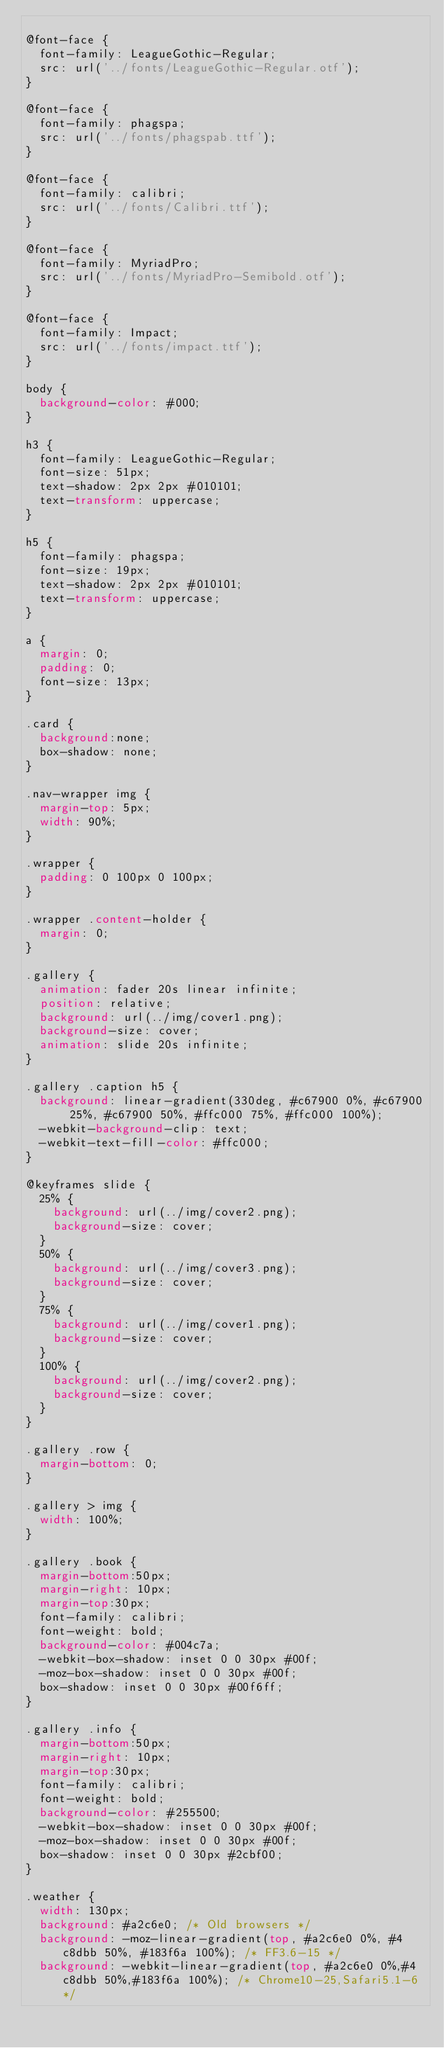<code> <loc_0><loc_0><loc_500><loc_500><_CSS_>
@font-face {
  font-family: LeagueGothic-Regular;
  src: url('../fonts/LeagueGothic-Regular.otf');
}

@font-face {
  font-family: phagspa;
  src: url('../fonts/phagspab.ttf');
}

@font-face {
  font-family: calibri;
  src: url('../fonts/Calibri.ttf');
}

@font-face {
  font-family: MyriadPro;
  src: url('../fonts/MyriadPro-Semibold.otf');
}

@font-face {
  font-family: Impact;
  src: url('../fonts/impact.ttf');
}

body {
  background-color: #000;
}

h3 {
  font-family: LeagueGothic-Regular;
  font-size: 51px;
  text-shadow: 2px 2px #010101;
  text-transform: uppercase;
}

h5 {
  font-family: phagspa;
  font-size: 19px;
  text-shadow: 2px 2px #010101;
  text-transform: uppercase;
}

a {
  margin: 0;
  padding: 0;
  font-size: 13px;
}

.card {
  background:none;
  box-shadow: none;
}

.nav-wrapper img {
  margin-top: 5px;
  width: 90%;
}

.wrapper {
  padding: 0 100px 0 100px;
}

.wrapper .content-holder {
  margin: 0;
}

.gallery {
  animation: fader 20s linear infinite;
  position: relative;
  background: url(../img/cover1.png);
  background-size: cover;
  animation: slide 20s infinite;
}

.gallery .caption h5 {
  background: linear-gradient(330deg, #c67900 0%, #c67900 25%, #c67900 50%, #ffc000 75%, #ffc000 100%);
  -webkit-background-clip: text;
  -webkit-text-fill-color: #ffc000;
}

@keyframes slide {
  25% {
    background: url(../img/cover2.png);
    background-size: cover;
  }
  50% {
    background: url(../img/cover3.png);
    background-size: cover;
  }
  75% {
    background: url(../img/cover1.png);
    background-size: cover;
  }
  100% {
    background: url(../img/cover2.png);
    background-size: cover;
  }
}

.gallery .row {
  margin-bottom: 0;
}

.gallery > img {
  width: 100%;
}

.gallery .book {
  margin-bottom:50px;
  margin-right: 10px;
  margin-top:30px;
  font-family: calibri;
  font-weight: bold;
  background-color: #004c7a;
  -webkit-box-shadow: inset 0 0 30px #00f;
  -moz-box-shadow: inset 0 0 30px #00f;
  box-shadow: inset 0 0 30px #00f6ff;
}

.gallery .info {
  margin-bottom:50px;
  margin-right: 10px;
  margin-top:30px;
  font-family: calibri;
  font-weight: bold;
  background-color: #255500;
  -webkit-box-shadow: inset 0 0 30px #00f;
  -moz-box-shadow: inset 0 0 30px #00f;
  box-shadow: inset 0 0 30px #2cbf00;
}

.weather {
  width: 130px;
  background: #a2c6e0; /* Old browsers */
  background: -moz-linear-gradient(top, #a2c6e0 0%, #4c8dbb 50%, #183f6a 100%); /* FF3.6-15 */
  background: -webkit-linear-gradient(top, #a2c6e0 0%,#4c8dbb 50%,#183f6a 100%); /* Chrome10-25,Safari5.1-6 */</code> 